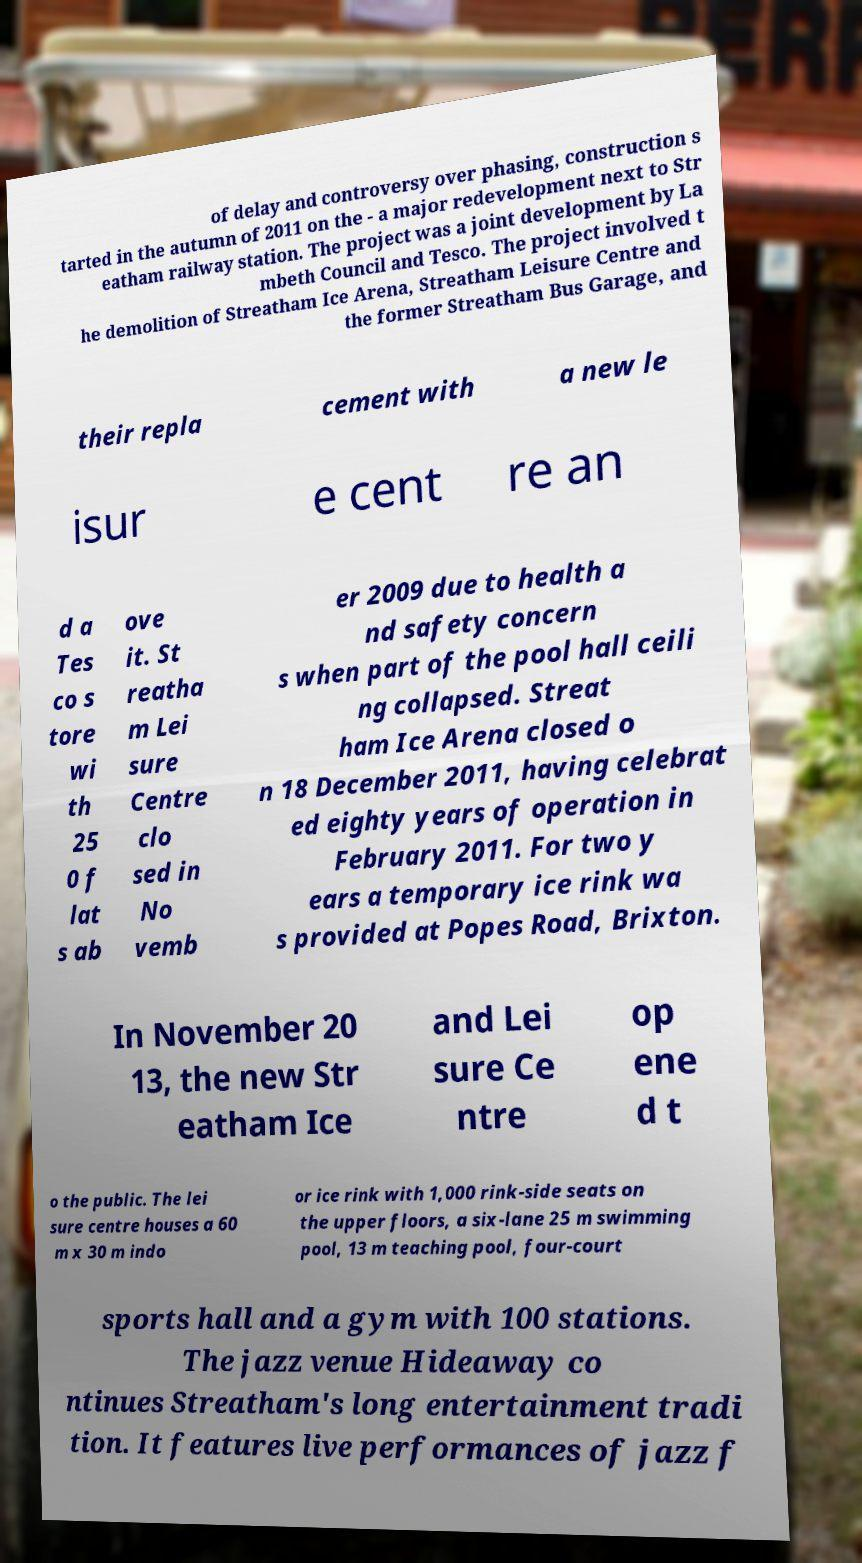Please read and relay the text visible in this image. What does it say? of delay and controversy over phasing, construction s tarted in the autumn of 2011 on the - a major redevelopment next to Str eatham railway station. The project was a joint development by La mbeth Council and Tesco. The project involved t he demolition of Streatham Ice Arena, Streatham Leisure Centre and the former Streatham Bus Garage, and their repla cement with a new le isur e cent re an d a Tes co s tore wi th 25 0 f lat s ab ove it. St reatha m Lei sure Centre clo sed in No vemb er 2009 due to health a nd safety concern s when part of the pool hall ceili ng collapsed. Streat ham Ice Arena closed o n 18 December 2011, having celebrat ed eighty years of operation in February 2011. For two y ears a temporary ice rink wa s provided at Popes Road, Brixton. In November 20 13, the new Str eatham Ice and Lei sure Ce ntre op ene d t o the public. The lei sure centre houses a 60 m x 30 m indo or ice rink with 1,000 rink-side seats on the upper floors, a six-lane 25 m swimming pool, 13 m teaching pool, four-court sports hall and a gym with 100 stations. The jazz venue Hideaway co ntinues Streatham's long entertainment tradi tion. It features live performances of jazz f 